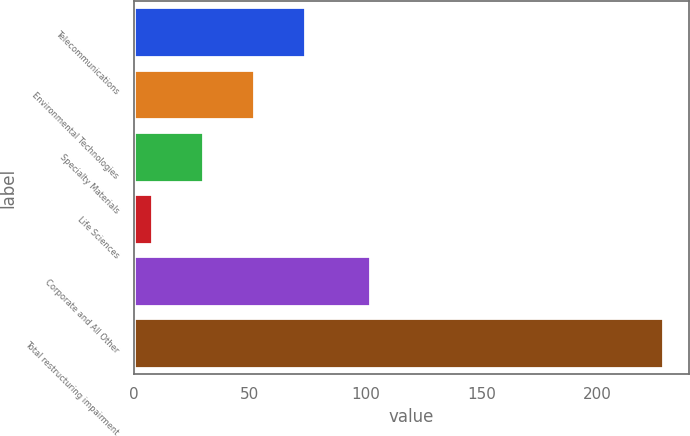Convert chart. <chart><loc_0><loc_0><loc_500><loc_500><bar_chart><fcel>Telecommunications<fcel>Environmental Technologies<fcel>Specialty Materials<fcel>Life Sciences<fcel>Corporate and All Other<fcel>Total restructuring impairment<nl><fcel>74<fcel>52<fcel>30<fcel>8<fcel>102<fcel>228<nl></chart> 